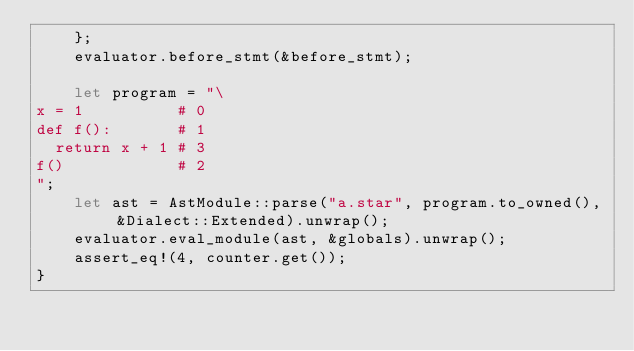Convert code to text. <code><loc_0><loc_0><loc_500><loc_500><_Rust_>    };
    evaluator.before_stmt(&before_stmt);

    let program = "\
x = 1          # 0
def f():       # 1
  return x + 1 # 3
f()            # 2
";
    let ast = AstModule::parse("a.star", program.to_owned(), &Dialect::Extended).unwrap();
    evaluator.eval_module(ast, &globals).unwrap();
    assert_eq!(4, counter.get());
}
</code> 